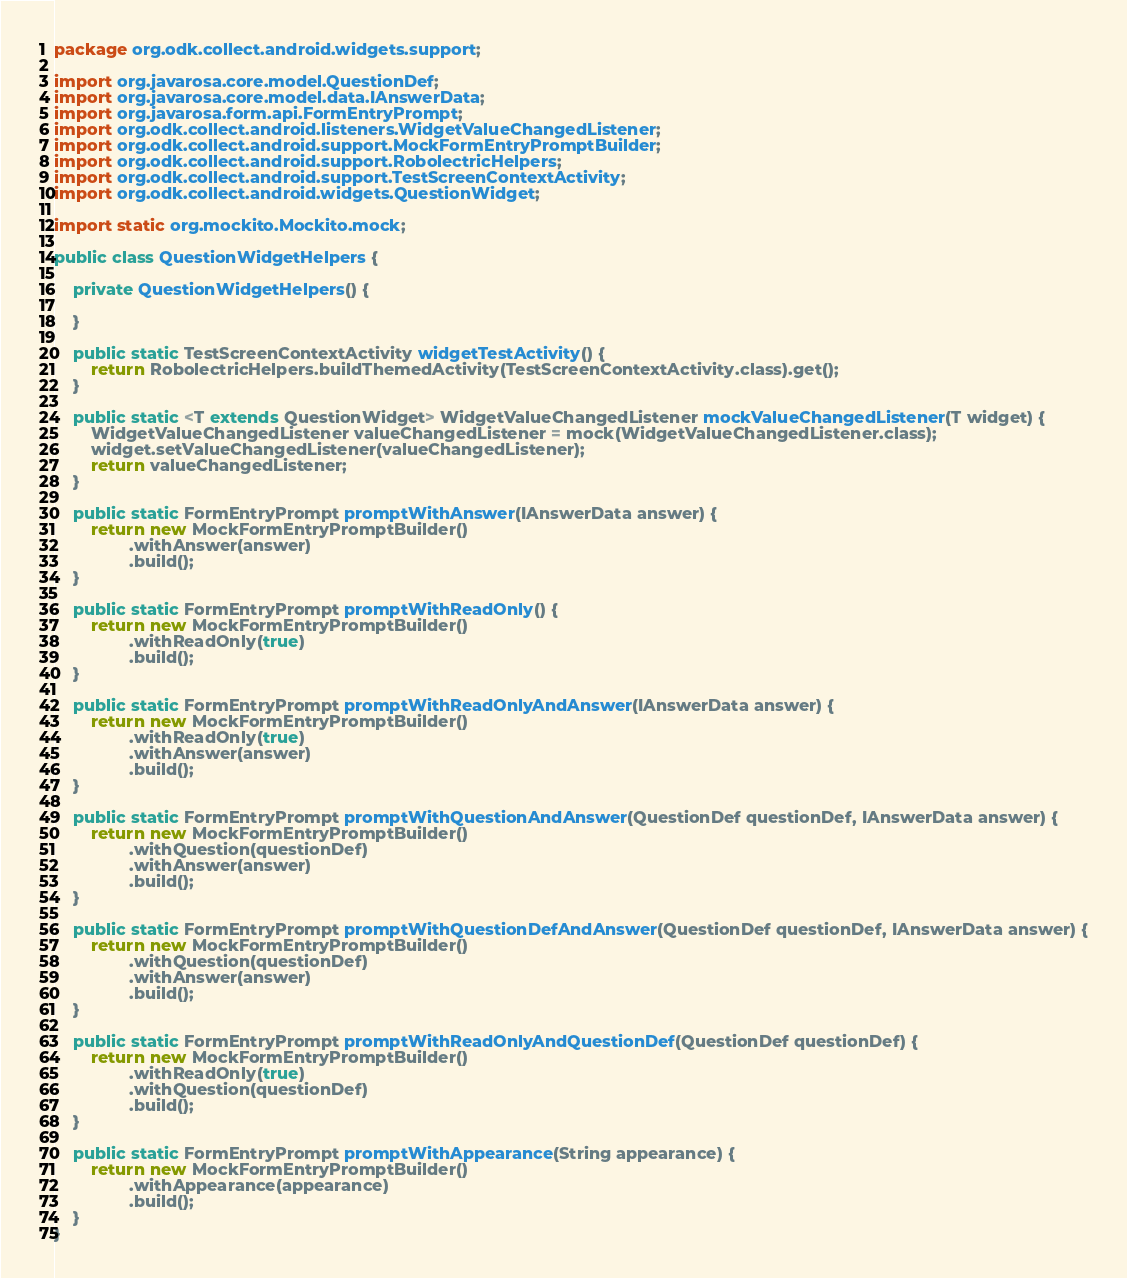<code> <loc_0><loc_0><loc_500><loc_500><_Java_>package org.odk.collect.android.widgets.support;

import org.javarosa.core.model.QuestionDef;
import org.javarosa.core.model.data.IAnswerData;
import org.javarosa.form.api.FormEntryPrompt;
import org.odk.collect.android.listeners.WidgetValueChangedListener;
import org.odk.collect.android.support.MockFormEntryPromptBuilder;
import org.odk.collect.android.support.RobolectricHelpers;
import org.odk.collect.android.support.TestScreenContextActivity;
import org.odk.collect.android.widgets.QuestionWidget;

import static org.mockito.Mockito.mock;

public class QuestionWidgetHelpers {

    private QuestionWidgetHelpers() {

    }

    public static TestScreenContextActivity widgetTestActivity() {
        return RobolectricHelpers.buildThemedActivity(TestScreenContextActivity.class).get();
    }

    public static <T extends QuestionWidget> WidgetValueChangedListener mockValueChangedListener(T widget) {
        WidgetValueChangedListener valueChangedListener = mock(WidgetValueChangedListener.class);
        widget.setValueChangedListener(valueChangedListener);
        return valueChangedListener;
    }

    public static FormEntryPrompt promptWithAnswer(IAnswerData answer) {
        return new MockFormEntryPromptBuilder()
                .withAnswer(answer)
                .build();
    }

    public static FormEntryPrompt promptWithReadOnly() {
        return new MockFormEntryPromptBuilder()
                .withReadOnly(true)
                .build();
    }

    public static FormEntryPrompt promptWithReadOnlyAndAnswer(IAnswerData answer) {
        return new MockFormEntryPromptBuilder()
                .withReadOnly(true)
                .withAnswer(answer)
                .build();
    }

    public static FormEntryPrompt promptWithQuestionAndAnswer(QuestionDef questionDef, IAnswerData answer) {
        return new MockFormEntryPromptBuilder()
                .withQuestion(questionDef)
                .withAnswer(answer)
                .build();
    }

    public static FormEntryPrompt promptWithQuestionDefAndAnswer(QuestionDef questionDef, IAnswerData answer) {
        return new MockFormEntryPromptBuilder()
                .withQuestion(questionDef)
                .withAnswer(answer)
                .build();
    }

    public static FormEntryPrompt promptWithReadOnlyAndQuestionDef(QuestionDef questionDef) {
        return new MockFormEntryPromptBuilder()
                .withReadOnly(true)
                .withQuestion(questionDef)
                .build();
    }

    public static FormEntryPrompt promptWithAppearance(String appearance) {
        return new MockFormEntryPromptBuilder()
                .withAppearance(appearance)
                .build();
    }
}
</code> 